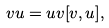<formula> <loc_0><loc_0><loc_500><loc_500>v u = u v [ v , u ] ,</formula> 